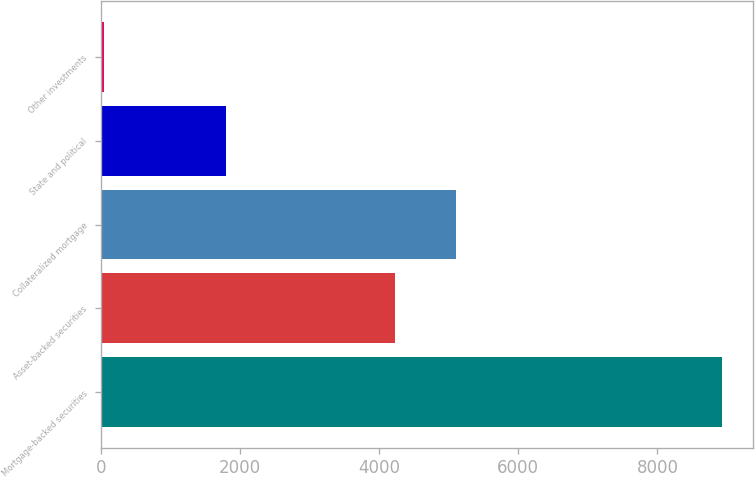Convert chart to OTSL. <chart><loc_0><loc_0><loc_500><loc_500><bar_chart><fcel>Mortgage-backed securities<fcel>Asset-backed securities<fcel>Collateralized mortgage<fcel>State and political<fcel>Other investments<nl><fcel>8933<fcel>4221<fcel>5109.9<fcel>1802<fcel>44<nl></chart> 